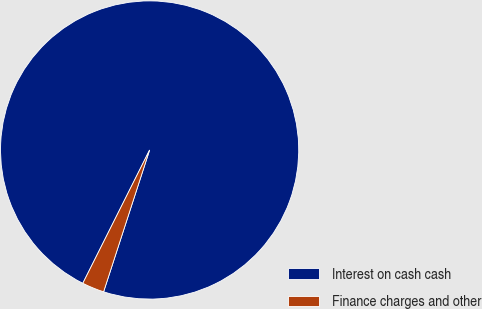<chart> <loc_0><loc_0><loc_500><loc_500><pie_chart><fcel>Interest on cash cash<fcel>Finance charges and other<nl><fcel>97.6%<fcel>2.4%<nl></chart> 